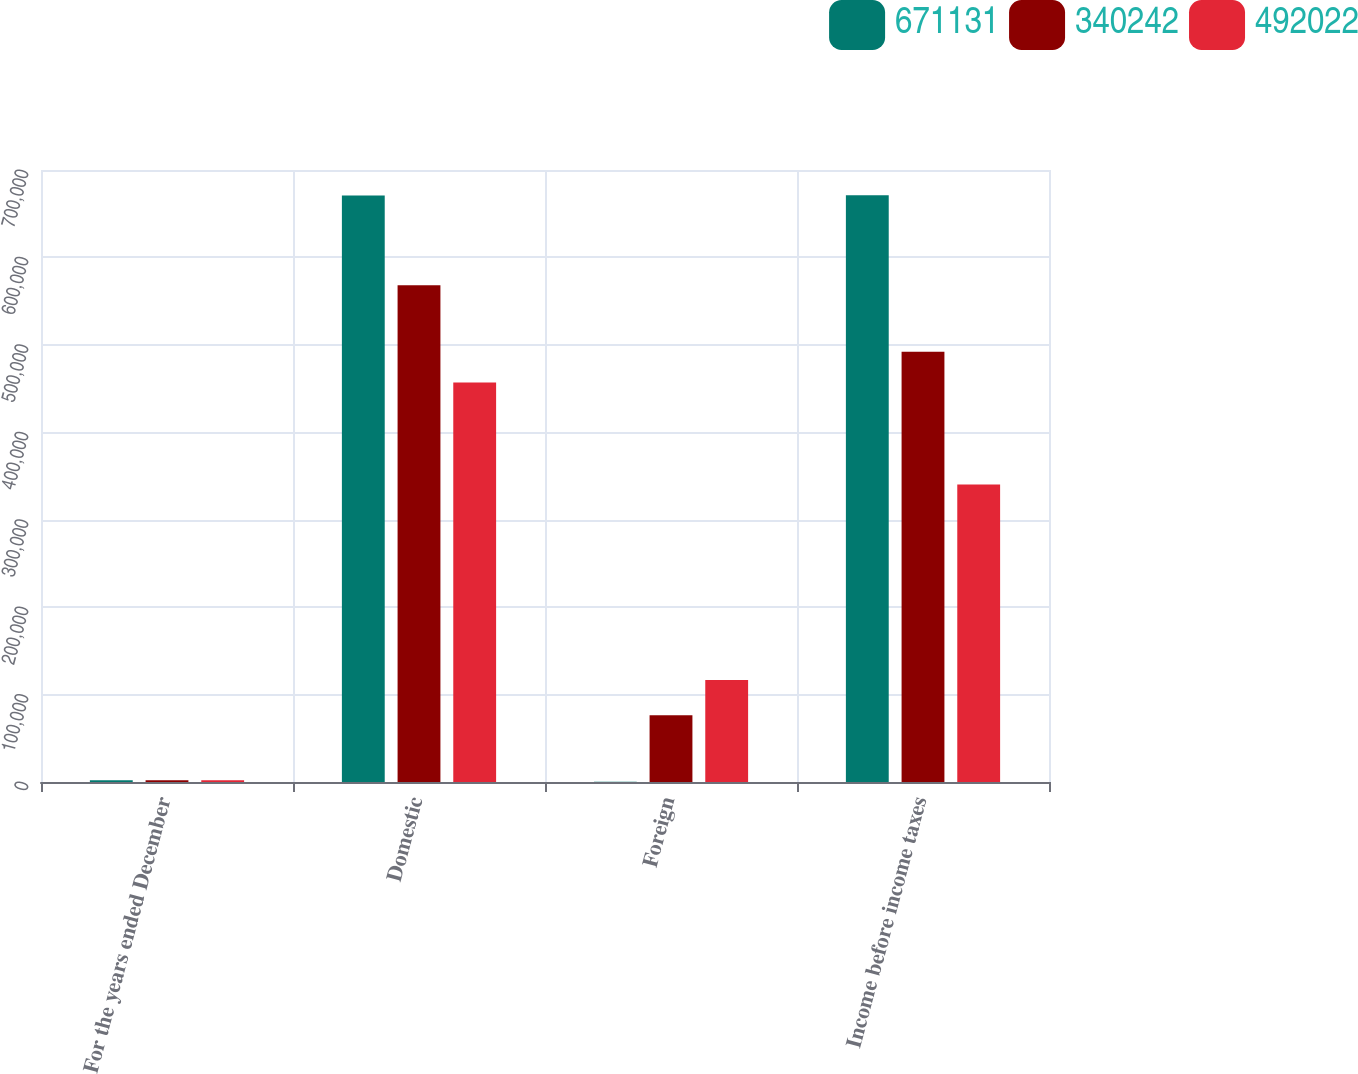<chart> <loc_0><loc_0><loc_500><loc_500><stacked_bar_chart><ecel><fcel>For the years ended December<fcel>Domestic<fcel>Foreign<fcel>Income before income taxes<nl><fcel>671131<fcel>2009<fcel>670753<fcel>378<fcel>671131<nl><fcel>340242<fcel>2008<fcel>568282<fcel>76260<fcel>492022<nl><fcel>492022<fcel>2007<fcel>456856<fcel>116614<fcel>340242<nl></chart> 